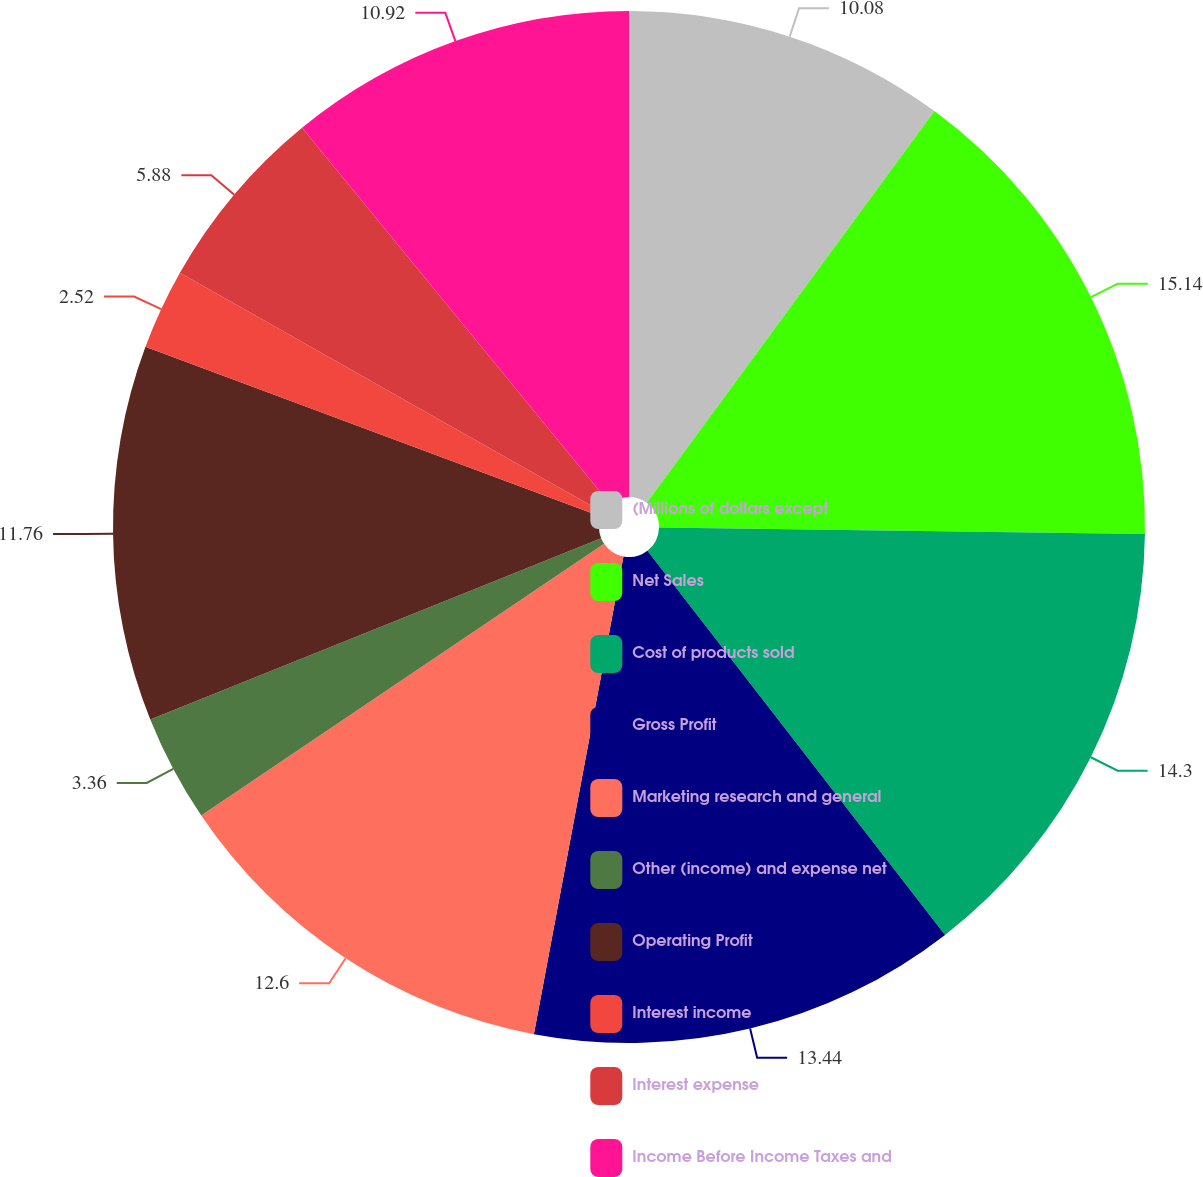Convert chart to OTSL. <chart><loc_0><loc_0><loc_500><loc_500><pie_chart><fcel>(Millions of dollars except<fcel>Net Sales<fcel>Cost of products sold<fcel>Gross Profit<fcel>Marketing research and general<fcel>Other (income) and expense net<fcel>Operating Profit<fcel>Interest income<fcel>Interest expense<fcel>Income Before Income Taxes and<nl><fcel>10.08%<fcel>15.13%<fcel>14.29%<fcel>13.44%<fcel>12.6%<fcel>3.36%<fcel>11.76%<fcel>2.52%<fcel>5.88%<fcel>10.92%<nl></chart> 